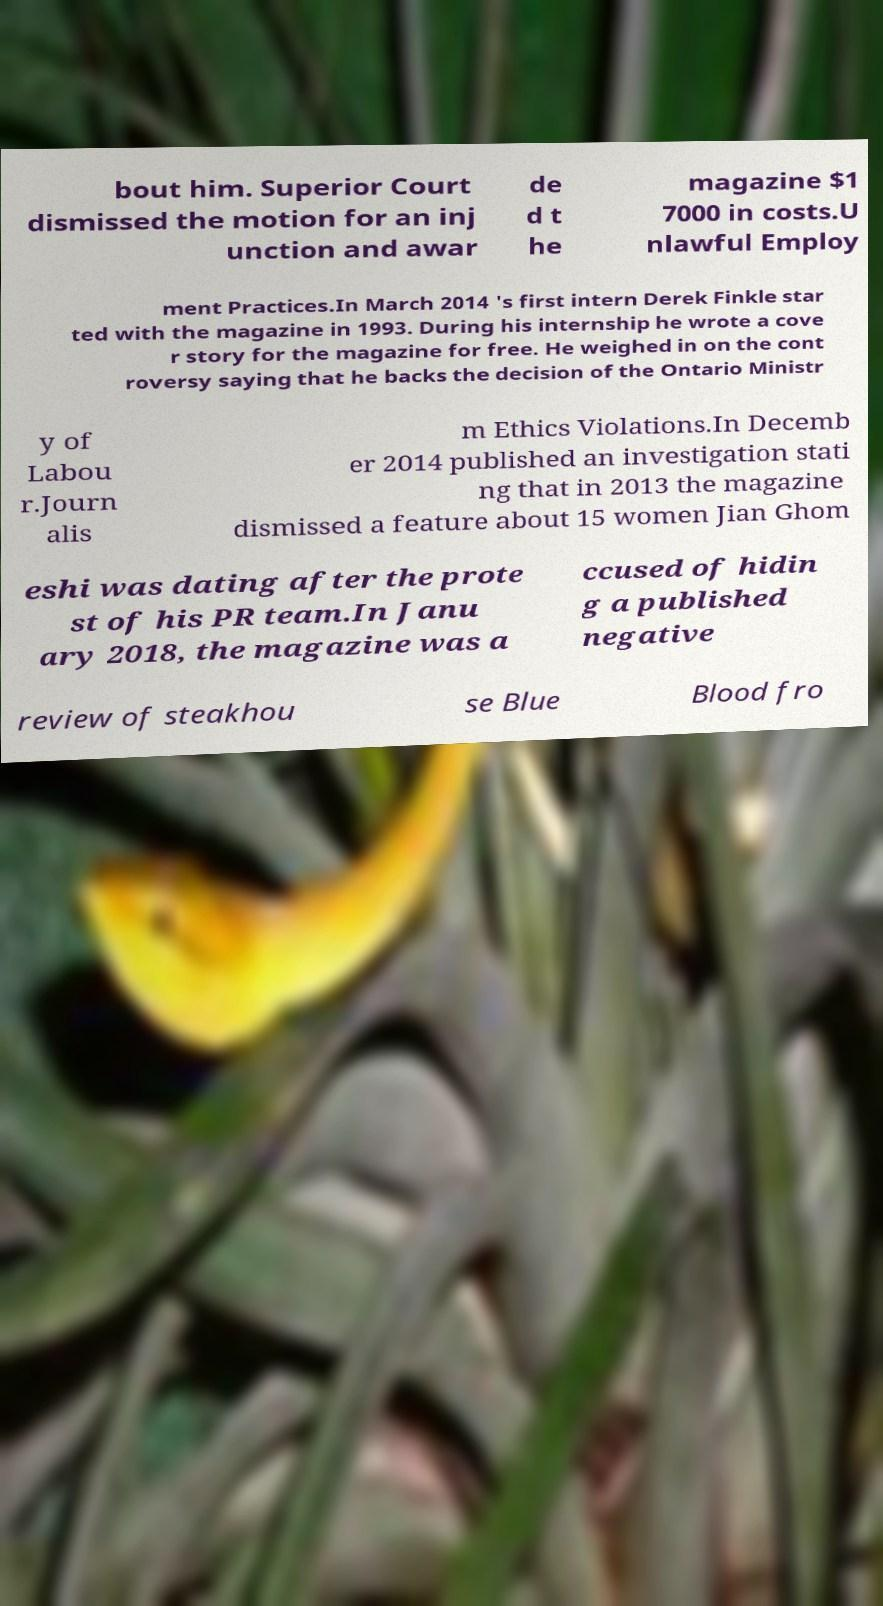For documentation purposes, I need the text within this image transcribed. Could you provide that? bout him. Superior Court dismissed the motion for an inj unction and awar de d t he magazine $1 7000 in costs.U nlawful Employ ment Practices.In March 2014 's first intern Derek Finkle star ted with the magazine in 1993. During his internship he wrote a cove r story for the magazine for free. He weighed in on the cont roversy saying that he backs the decision of the Ontario Ministr y of Labou r.Journ alis m Ethics Violations.In Decemb er 2014 published an investigation stati ng that in 2013 the magazine dismissed a feature about 15 women Jian Ghom eshi was dating after the prote st of his PR team.In Janu ary 2018, the magazine was a ccused of hidin g a published negative review of steakhou se Blue Blood fro 